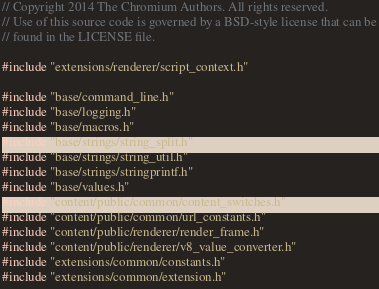Convert code to text. <code><loc_0><loc_0><loc_500><loc_500><_C++_>// Copyright 2014 The Chromium Authors. All rights reserved.
// Use of this source code is governed by a BSD-style license that can be
// found in the LICENSE file.

#include "extensions/renderer/script_context.h"

#include "base/command_line.h"
#include "base/logging.h"
#include "base/macros.h"
#include "base/strings/string_split.h"
#include "base/strings/string_util.h"
#include "base/strings/stringprintf.h"
#include "base/values.h"
#include "content/public/common/content_switches.h"
#include "content/public/common/url_constants.h"
#include "content/public/renderer/render_frame.h"
#include "content/public/renderer/v8_value_converter.h"
#include "extensions/common/constants.h"
#include "extensions/common/extension.h"</code> 